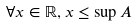<formula> <loc_0><loc_0><loc_500><loc_500>\forall x \in \mathbb { R } , x \leq \sup A</formula> 